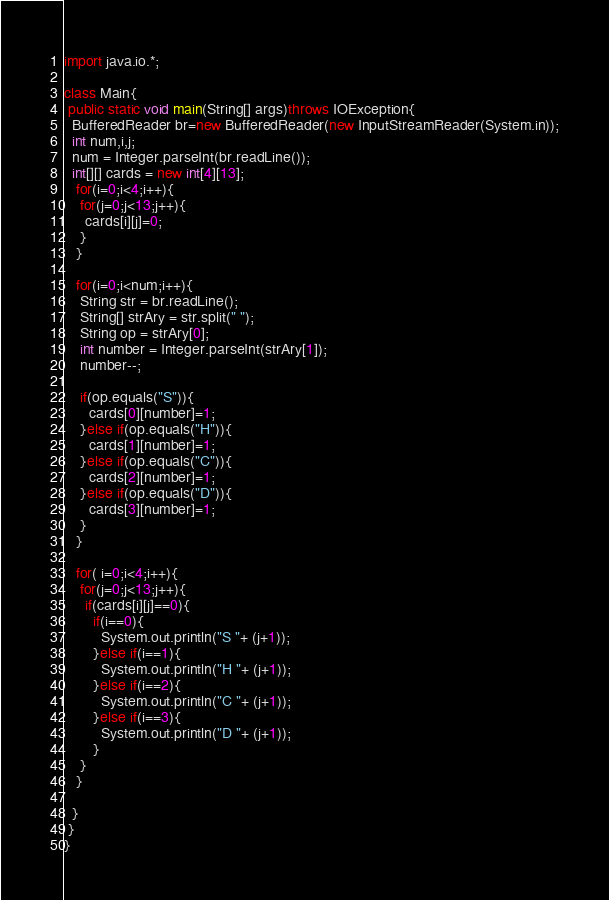Convert code to text. <code><loc_0><loc_0><loc_500><loc_500><_Java_>import java.io.*;

class Main{
 public static void main(String[] args)throws IOException{
  BufferedReader br=new BufferedReader(new InputStreamReader(System.in));
  int num,i,j;
  num = Integer.parseInt(br.readLine());
  int[][] cards = new int[4][13];   
   for(i=0;i<4;i++){
    for(j=0;j<13;j++){
     cards[i][j]=0;
    }
   }

   for(i=0;i<num;i++){ 
    String str = br.readLine(); 
    String[] strAry = str.split(" ");
    String op = strAry[0];
    int number = Integer.parseInt(strAry[1]);
    number--;   

    if(op.equals("S")){            
      cards[0][number]=1; 
    }else if(op.equals("H")){
      cards[1][number]=1;
    }else if(op.equals("C")){
      cards[2][number]=1;
    }else if(op.equals("D")){
      cards[3][number]=1;
    }
   }
    
   for( i=0;i<4;i++){
    for(j=0;j<13;j++){
     if(cards[i][j]==0){
       if(i==0){   
         System.out.println("S "+ (j+1));     
       }else if(i==1){
         System.out.println("H "+ (j+1));
       }else if(i==2){
         System.out.println("C "+ (j+1));
       }else if(i==3){
         System.out.println("D "+ (j+1));
       }
    }
   }
   
  }
 }
}</code> 